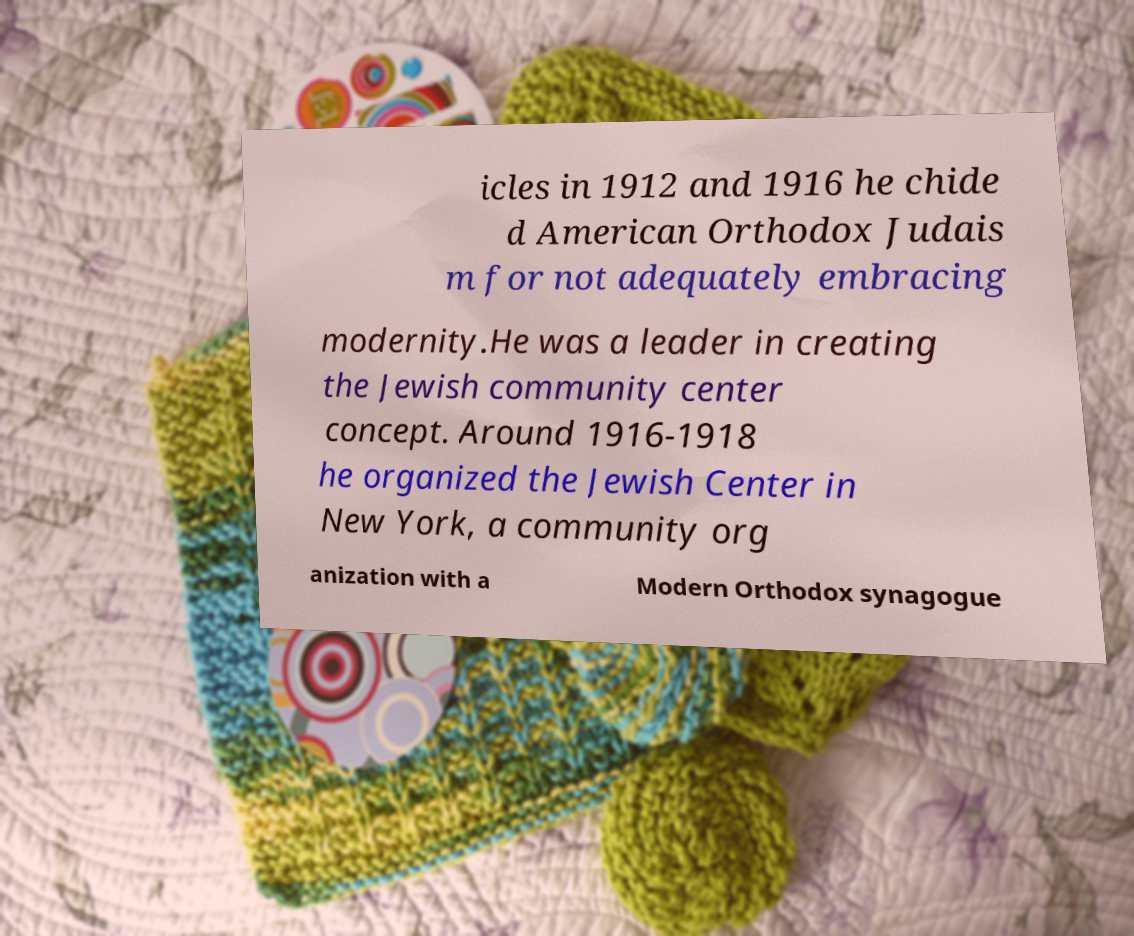Could you assist in decoding the text presented in this image and type it out clearly? icles in 1912 and 1916 he chide d American Orthodox Judais m for not adequately embracing modernity.He was a leader in creating the Jewish community center concept. Around 1916-1918 he organized the Jewish Center in New York, a community org anization with a Modern Orthodox synagogue 